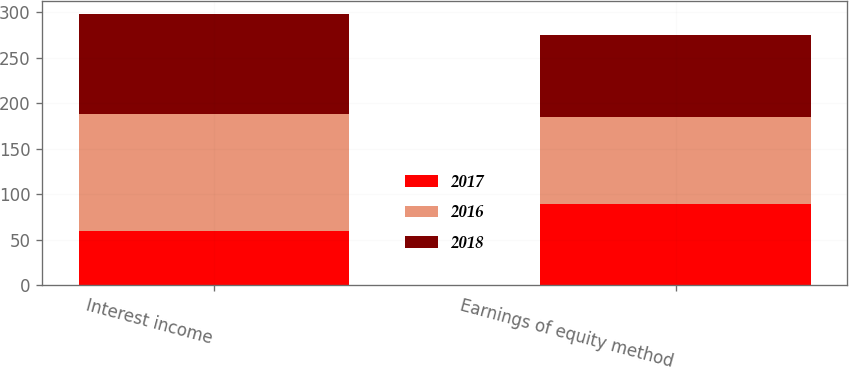<chart> <loc_0><loc_0><loc_500><loc_500><stacked_bar_chart><ecel><fcel>Interest income<fcel>Earnings of equity method<nl><fcel>2017<fcel>60<fcel>89<nl><fcel>2016<fcel>128<fcel>96<nl><fcel>2018<fcel>110<fcel>90<nl></chart> 